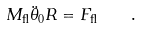Convert formula to latex. <formula><loc_0><loc_0><loc_500><loc_500>M _ { \text {fl} } \ddot { \theta } _ { 0 } R = { F } _ { \text {fl} } \quad .</formula> 